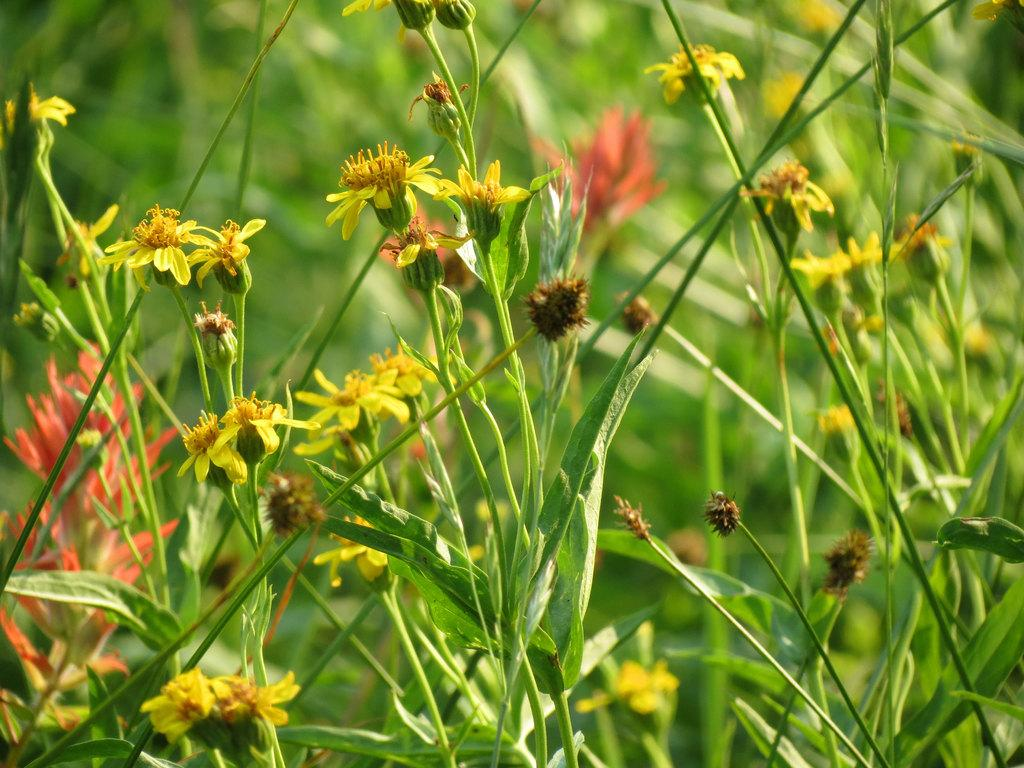What types of living organisms can be seen in the image? Plants and flowers are visible in the image. What color is predominant in the background of the image? The background of the image is green. How many times did the flowers adjust their position in the image? There is no indication in the image that the flowers moved or adjusted their position. 